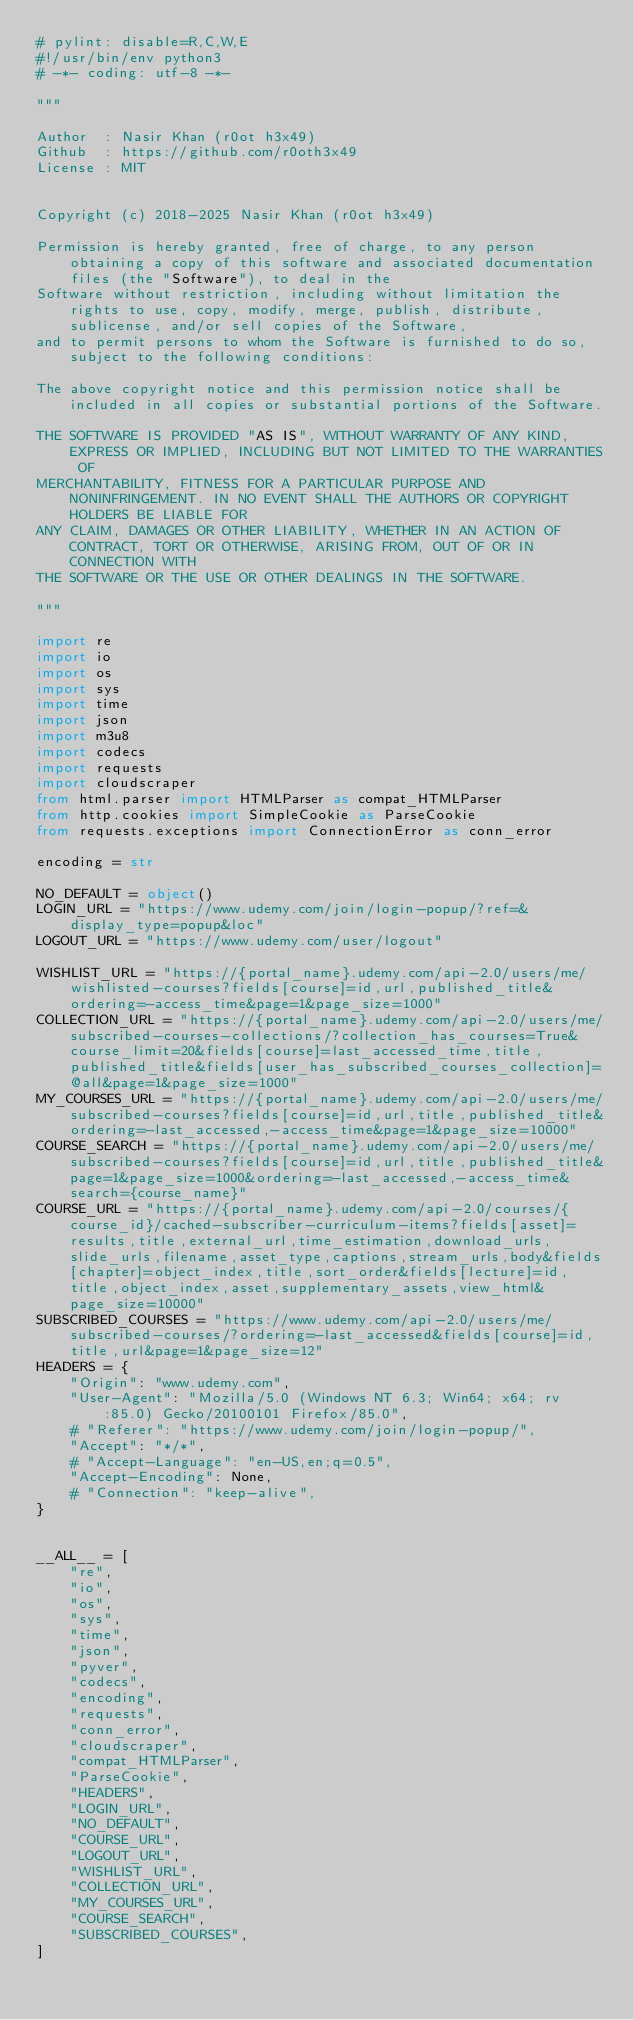Convert code to text. <code><loc_0><loc_0><loc_500><loc_500><_Python_># pylint: disable=R,C,W,E
#!/usr/bin/env python3
# -*- coding: utf-8 -*-

"""

Author  : Nasir Khan (r0ot h3x49)
Github  : https://github.com/r0oth3x49
License : MIT


Copyright (c) 2018-2025 Nasir Khan (r0ot h3x49)

Permission is hereby granted, free of charge, to any person obtaining a copy of this software and associated documentation files (the "Software"), to deal in the
Software without restriction, including without limitation the rights to use, copy, modify, merge, publish, distribute, sublicense, and/or sell copies of the Software, 
and to permit persons to whom the Software is furnished to do so, subject to the following conditions:

The above copyright notice and this permission notice shall be included in all copies or substantial portions of the Software.

THE SOFTWARE IS PROVIDED "AS IS", WITHOUT WARRANTY OF ANY KIND, EXPRESS OR IMPLIED, INCLUDING BUT NOT LIMITED TO THE WARRANTIES OF
MERCHANTABILITY, FITNESS FOR A PARTICULAR PURPOSE AND NONINFRINGEMENT. IN NO EVENT SHALL THE AUTHORS OR COPYRIGHT HOLDERS BE LIABLE FOR
ANY CLAIM, DAMAGES OR OTHER LIABILITY, WHETHER IN AN ACTION OF CONTRACT, TORT OR OTHERWISE, ARISING FROM, OUT OF OR IN CONNECTION WITH 
THE SOFTWARE OR THE USE OR OTHER DEALINGS IN THE SOFTWARE.

"""

import re
import io
import os
import sys
import time
import json
import m3u8
import codecs
import requests
import cloudscraper
from html.parser import HTMLParser as compat_HTMLParser
from http.cookies import SimpleCookie as ParseCookie
from requests.exceptions import ConnectionError as conn_error

encoding = str

NO_DEFAULT = object()
LOGIN_URL = "https://www.udemy.com/join/login-popup/?ref=&display_type=popup&loc"
LOGOUT_URL = "https://www.udemy.com/user/logout"

WISHLIST_URL = "https://{portal_name}.udemy.com/api-2.0/users/me/wishlisted-courses?fields[course]=id,url,published_title&ordering=-access_time&page=1&page_size=1000"
COLLECTION_URL = "https://{portal_name}.udemy.com/api-2.0/users/me/subscribed-courses-collections/?collection_has_courses=True&course_limit=20&fields[course]=last_accessed_time,title,published_title&fields[user_has_subscribed_courses_collection]=@all&page=1&page_size=1000"
MY_COURSES_URL = "https://{portal_name}.udemy.com/api-2.0/users/me/subscribed-courses?fields[course]=id,url,title,published_title&ordering=-last_accessed,-access_time&page=1&page_size=10000"
COURSE_SEARCH = "https://{portal_name}.udemy.com/api-2.0/users/me/subscribed-courses?fields[course]=id,url,title,published_title&page=1&page_size=1000&ordering=-last_accessed,-access_time&search={course_name}"
COURSE_URL = "https://{portal_name}.udemy.com/api-2.0/courses/{course_id}/cached-subscriber-curriculum-items?fields[asset]=results,title,external_url,time_estimation,download_urls,slide_urls,filename,asset_type,captions,stream_urls,body&fields[chapter]=object_index,title,sort_order&fields[lecture]=id,title,object_index,asset,supplementary_assets,view_html&page_size=10000"
SUBSCRIBED_COURSES = "https://www.udemy.com/api-2.0/users/me/subscribed-courses/?ordering=-last_accessed&fields[course]=id,title,url&page=1&page_size=12"
HEADERS = {
    "Origin": "www.udemy.com",
    "User-Agent": "Mozilla/5.0 (Windows NT 6.3; Win64; x64; rv:85.0) Gecko/20100101 Firefox/85.0",
    # "Referer": "https://www.udemy.com/join/login-popup/",
    "Accept": "*/*",
    # "Accept-Language": "en-US,en;q=0.5",
    "Accept-Encoding": None,
    # "Connection": "keep-alive",
}


__ALL__ = [
    "re",
    "io",
    "os",
    "sys",
    "time",
    "json",
    "pyver",
    "codecs",
    "encoding",
    "requests",
    "conn_error",
    "cloudscraper",
    "compat_HTMLParser",
    "ParseCookie",
    "HEADERS",
    "LOGIN_URL",
    "NO_DEFAULT",
    "COURSE_URL",
    "LOGOUT_URL",
    "WISHLIST_URL",
    "COLLECTION_URL",
    "MY_COURSES_URL",
    "COURSE_SEARCH",
    "SUBSCRIBED_COURSES",
]
</code> 